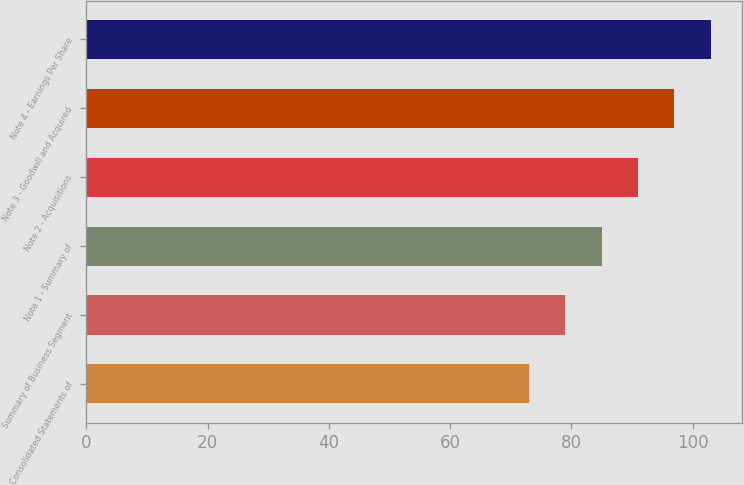Convert chart. <chart><loc_0><loc_0><loc_500><loc_500><bar_chart><fcel>Consolidated Statements of<fcel>Summary of Business Segment<fcel>Note 1 - Summary of<fcel>Note 2 - Acquisitions<fcel>Note 3 - Goodwill and Acquired<fcel>Note 4 - Earnings Per Share<nl><fcel>73<fcel>79<fcel>85<fcel>91<fcel>97<fcel>103<nl></chart> 